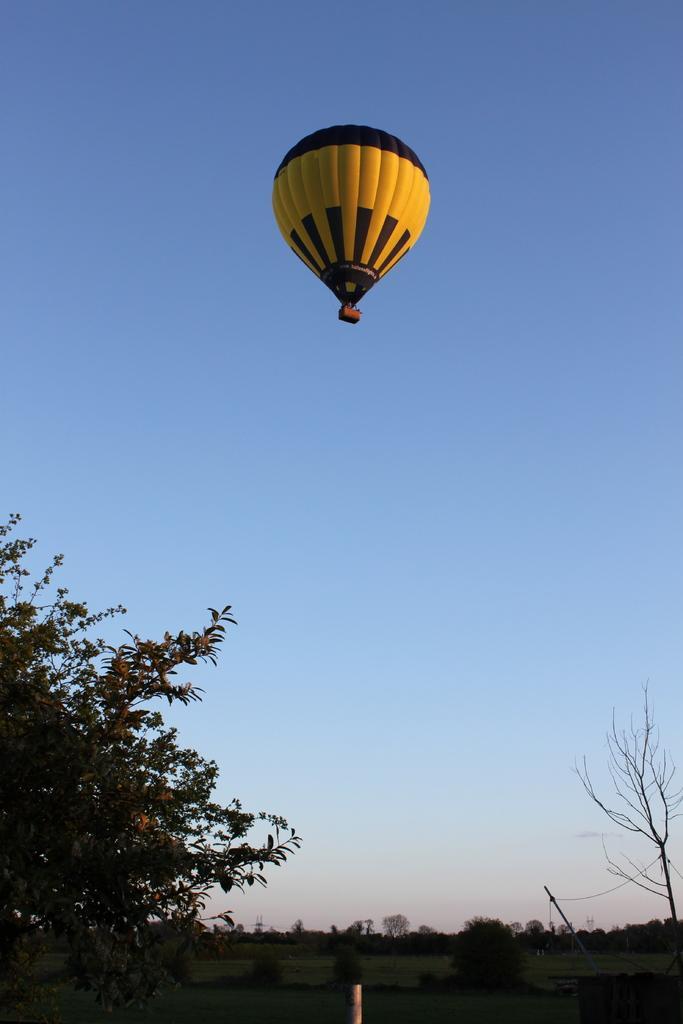Describe this image in one or two sentences. In this image at the bottom I can see trees, pole, at the top there is a parachute and the sky. 